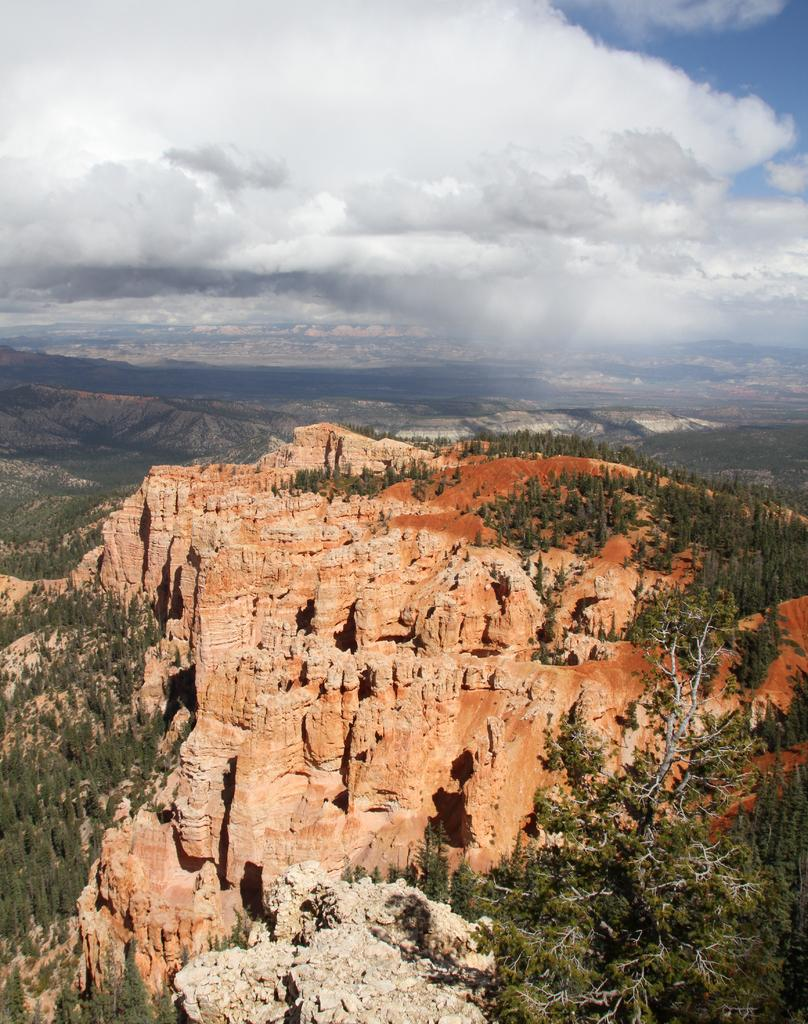What type of natural landscape is depicted in the image? The image features mountains. What other natural elements can be seen in the image? There are trees and a rock visible in the image. What is visible in the sky in the image? The sky is visible in the image, and there are clouds present. What flavor of cough syrup is being advertised on the rock in the image? There is no cough syrup or advertisement present in the image; it features mountains, trees, a rock, and clouds in the sky. How many fingers are visible on the trees in the image? Trees do not have fingers, so this question cannot be answered definitively based on the provided facts. 